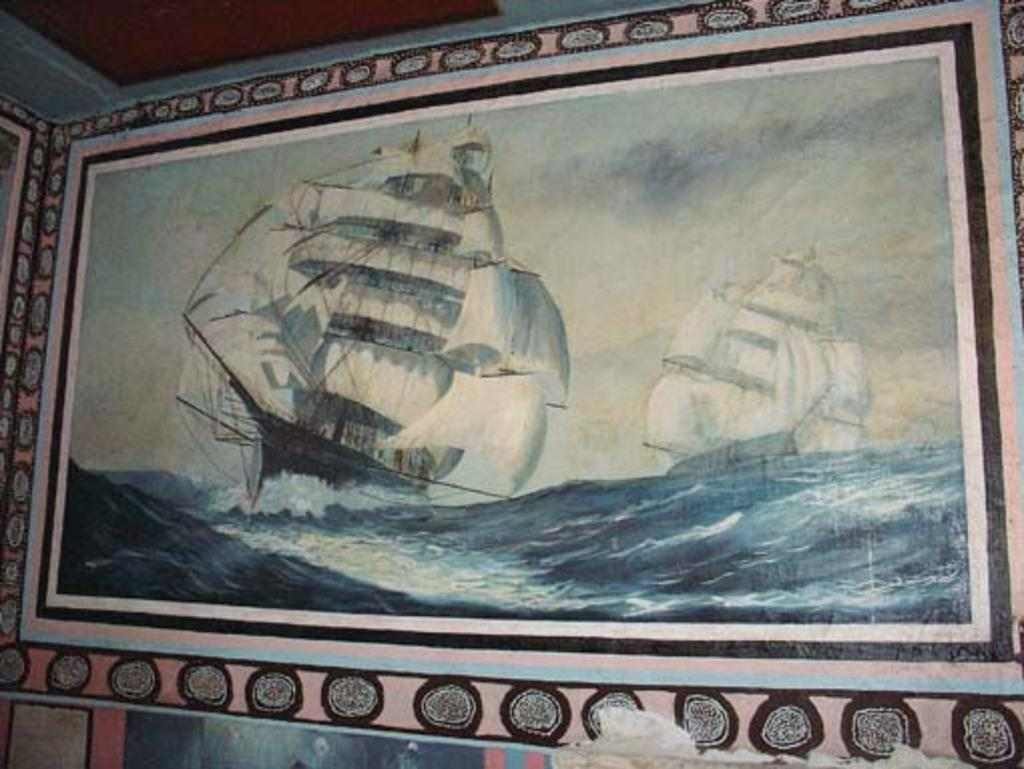What is hanging on the wall in the image? There is a painting on the wall in the image. What type of coat is the person wearing in the image? There is no person wearing a coat in the image, as the only fact provided is about a painting on the wall. 